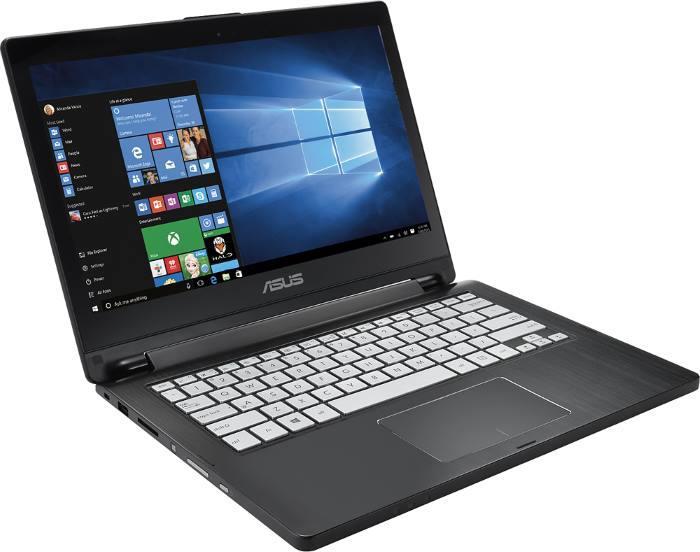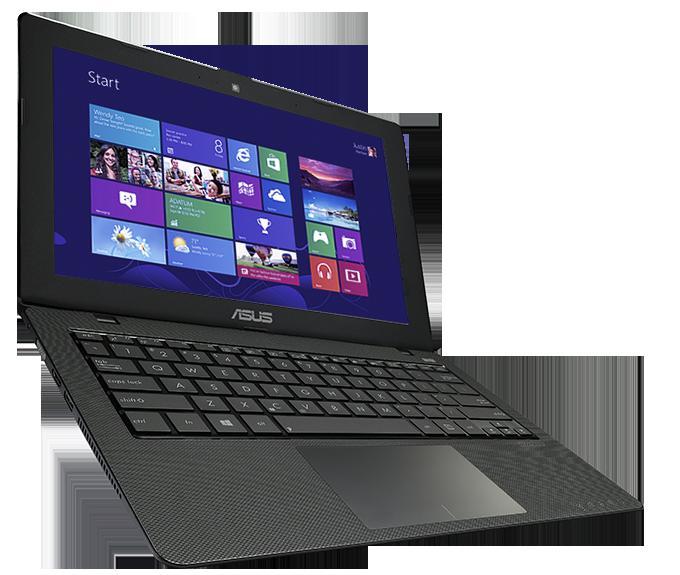The first image is the image on the left, the second image is the image on the right. Given the left and right images, does the statement "some keyboards have white/gray keys." hold true? Answer yes or no. Yes. The first image is the image on the left, the second image is the image on the right. Given the left and right images, does the statement "Each image shows a single open laptop, and each laptop is open to an angle of at least 90 degrees." hold true? Answer yes or no. Yes. 